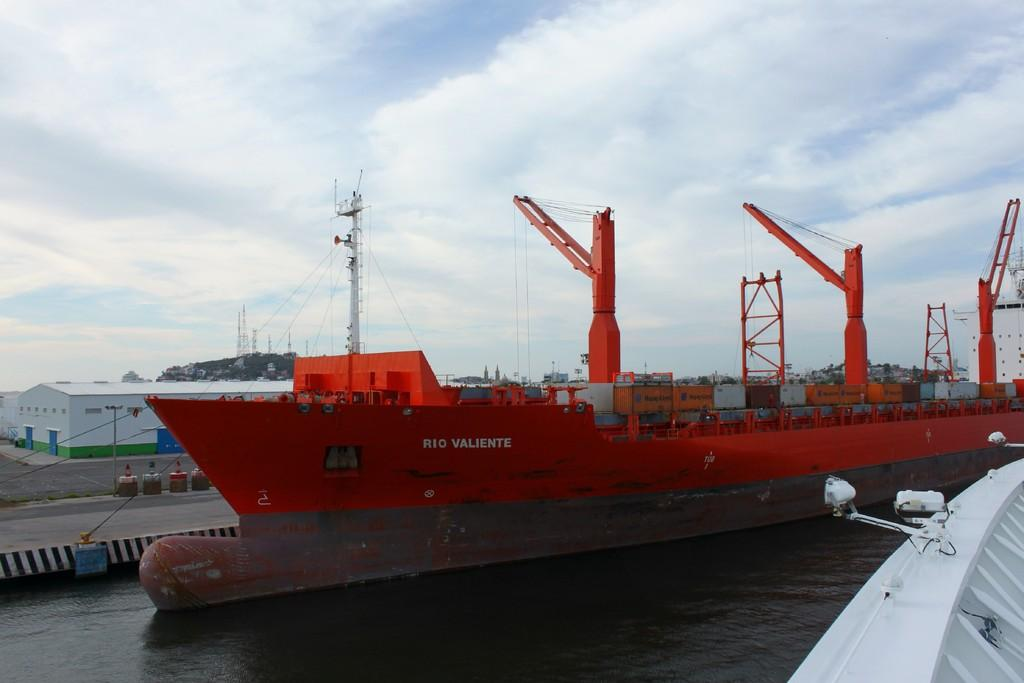<image>
Present a compact description of the photo's key features. The Rio Valentine is a huge red ship parked at this bay 